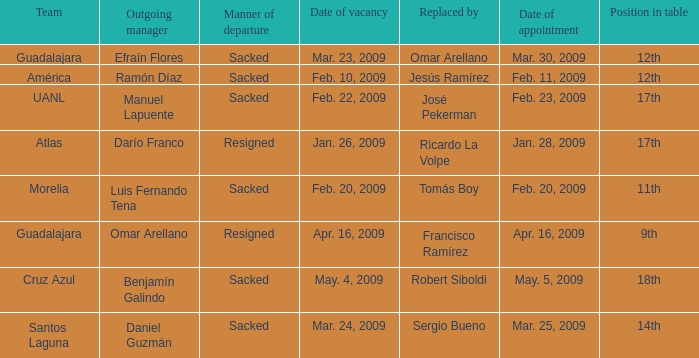What is Position in Table, when Replaced By is "Sergio Bueno"? 14th. 